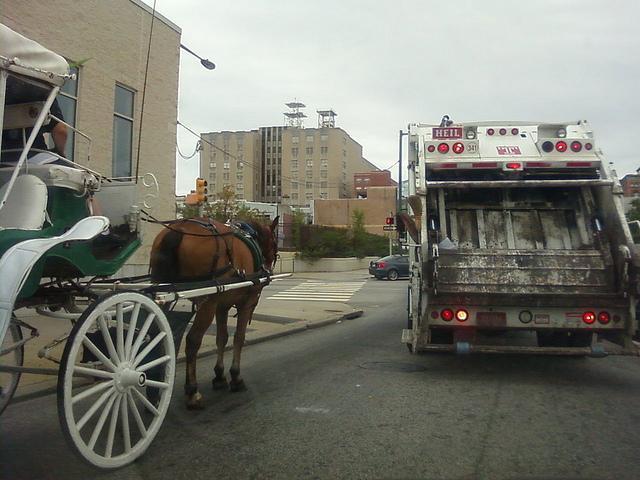Is the given caption "The horse is at the back of the truck." fitting for the image?
Answer yes or no. Yes. 